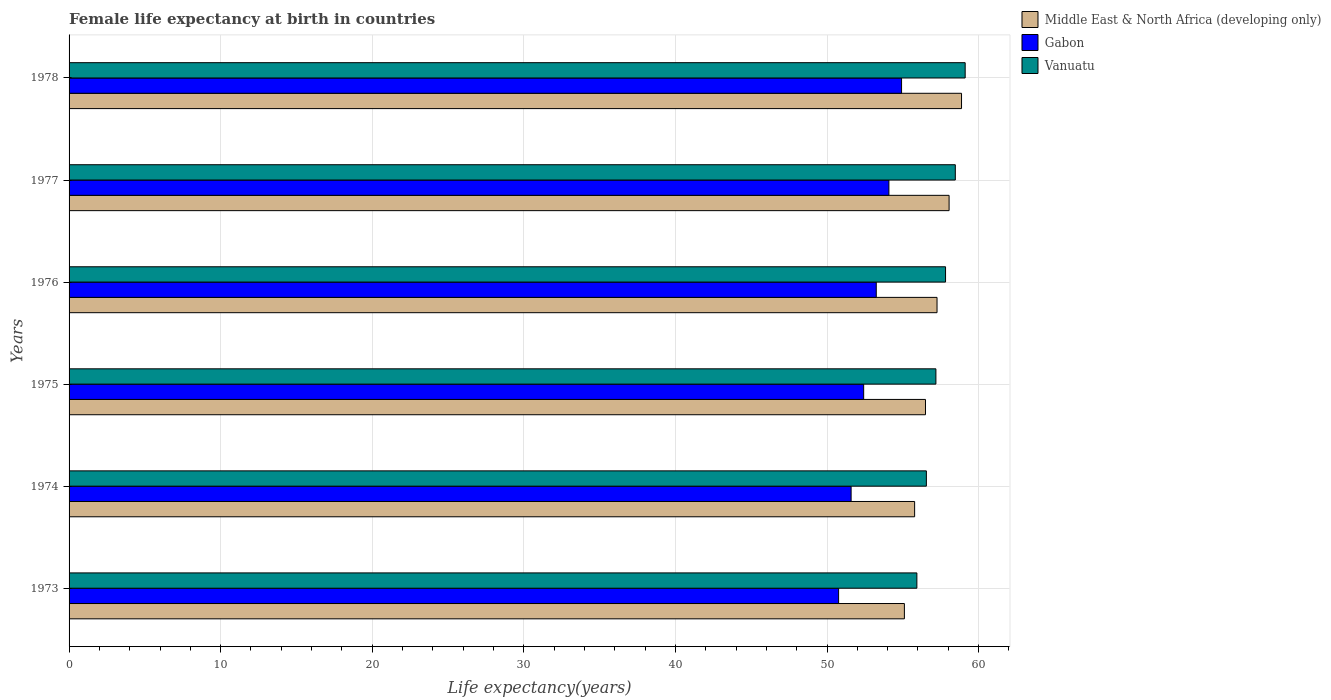How many different coloured bars are there?
Give a very brief answer. 3. How many groups of bars are there?
Offer a very short reply. 6. How many bars are there on the 1st tick from the top?
Your response must be concise. 3. How many bars are there on the 1st tick from the bottom?
Ensure brevity in your answer.  3. What is the label of the 3rd group of bars from the top?
Make the answer very short. 1976. What is the female life expectancy at birth in Middle East & North Africa (developing only) in 1975?
Your answer should be compact. 56.5. Across all years, what is the maximum female life expectancy at birth in Gabon?
Make the answer very short. 54.92. Across all years, what is the minimum female life expectancy at birth in Vanuatu?
Offer a terse response. 55.93. In which year was the female life expectancy at birth in Middle East & North Africa (developing only) maximum?
Provide a short and direct response. 1978. What is the total female life expectancy at birth in Middle East & North Africa (developing only) in the graph?
Your answer should be compact. 341.56. What is the difference between the female life expectancy at birth in Gabon in 1974 and that in 1975?
Make the answer very short. -0.83. What is the difference between the female life expectancy at birth in Gabon in 1977 and the female life expectancy at birth in Vanuatu in 1974?
Your response must be concise. -2.47. What is the average female life expectancy at birth in Vanuatu per year?
Keep it short and to the point. 57.51. In the year 1974, what is the difference between the female life expectancy at birth in Gabon and female life expectancy at birth in Vanuatu?
Provide a short and direct response. -4.97. What is the ratio of the female life expectancy at birth in Middle East & North Africa (developing only) in 1973 to that in 1978?
Offer a very short reply. 0.94. Is the female life expectancy at birth in Gabon in 1975 less than that in 1977?
Provide a short and direct response. Yes. Is the difference between the female life expectancy at birth in Gabon in 1973 and 1974 greater than the difference between the female life expectancy at birth in Vanuatu in 1973 and 1974?
Your answer should be compact. No. What is the difference between the highest and the second highest female life expectancy at birth in Middle East & North Africa (developing only)?
Make the answer very short. 0.82. What is the difference between the highest and the lowest female life expectancy at birth in Vanuatu?
Offer a very short reply. 3.19. In how many years, is the female life expectancy at birth in Gabon greater than the average female life expectancy at birth in Gabon taken over all years?
Provide a short and direct response. 3. Is the sum of the female life expectancy at birth in Vanuatu in 1976 and 1978 greater than the maximum female life expectancy at birth in Gabon across all years?
Offer a terse response. Yes. What does the 3rd bar from the top in 1978 represents?
Provide a short and direct response. Middle East & North Africa (developing only). What does the 1st bar from the bottom in 1976 represents?
Your answer should be very brief. Middle East & North Africa (developing only). How many bars are there?
Give a very brief answer. 18. Does the graph contain grids?
Your answer should be compact. Yes. Where does the legend appear in the graph?
Keep it short and to the point. Top right. How many legend labels are there?
Make the answer very short. 3. How are the legend labels stacked?
Ensure brevity in your answer.  Vertical. What is the title of the graph?
Provide a succinct answer. Female life expectancy at birth in countries. What is the label or title of the X-axis?
Give a very brief answer. Life expectancy(years). What is the Life expectancy(years) in Middle East & North Africa (developing only) in 1973?
Your answer should be very brief. 55.1. What is the Life expectancy(years) of Gabon in 1973?
Offer a very short reply. 50.76. What is the Life expectancy(years) in Vanuatu in 1973?
Offer a terse response. 55.93. What is the Life expectancy(years) in Middle East & North Africa (developing only) in 1974?
Offer a very short reply. 55.78. What is the Life expectancy(years) of Gabon in 1974?
Offer a very short reply. 51.59. What is the Life expectancy(years) of Vanuatu in 1974?
Ensure brevity in your answer.  56.55. What is the Life expectancy(years) of Middle East & North Africa (developing only) in 1975?
Your answer should be very brief. 56.5. What is the Life expectancy(years) in Gabon in 1975?
Your answer should be very brief. 52.42. What is the Life expectancy(years) in Vanuatu in 1975?
Keep it short and to the point. 57.18. What is the Life expectancy(years) in Middle East & North Africa (developing only) in 1976?
Keep it short and to the point. 57.26. What is the Life expectancy(years) in Gabon in 1976?
Offer a terse response. 53.25. What is the Life expectancy(years) of Vanuatu in 1976?
Your answer should be compact. 57.82. What is the Life expectancy(years) in Middle East & North Africa (developing only) in 1977?
Make the answer very short. 58.05. What is the Life expectancy(years) in Gabon in 1977?
Make the answer very short. 54.08. What is the Life expectancy(years) in Vanuatu in 1977?
Make the answer very short. 58.46. What is the Life expectancy(years) of Middle East & North Africa (developing only) in 1978?
Make the answer very short. 58.87. What is the Life expectancy(years) in Gabon in 1978?
Your answer should be very brief. 54.92. What is the Life expectancy(years) of Vanuatu in 1978?
Your response must be concise. 59.11. Across all years, what is the maximum Life expectancy(years) in Middle East & North Africa (developing only)?
Keep it short and to the point. 58.87. Across all years, what is the maximum Life expectancy(years) in Gabon?
Give a very brief answer. 54.92. Across all years, what is the maximum Life expectancy(years) of Vanuatu?
Your response must be concise. 59.11. Across all years, what is the minimum Life expectancy(years) in Middle East & North Africa (developing only)?
Your answer should be very brief. 55.1. Across all years, what is the minimum Life expectancy(years) in Gabon?
Ensure brevity in your answer.  50.76. Across all years, what is the minimum Life expectancy(years) of Vanuatu?
Provide a succinct answer. 55.93. What is the total Life expectancy(years) in Middle East & North Africa (developing only) in the graph?
Provide a succinct answer. 341.56. What is the total Life expectancy(years) in Gabon in the graph?
Offer a very short reply. 317.02. What is the total Life expectancy(years) of Vanuatu in the graph?
Ensure brevity in your answer.  345.06. What is the difference between the Life expectancy(years) of Middle East & North Africa (developing only) in 1973 and that in 1974?
Your answer should be very brief. -0.67. What is the difference between the Life expectancy(years) in Gabon in 1973 and that in 1974?
Your answer should be very brief. -0.82. What is the difference between the Life expectancy(years) in Vanuatu in 1973 and that in 1974?
Make the answer very short. -0.63. What is the difference between the Life expectancy(years) in Middle East & North Africa (developing only) in 1973 and that in 1975?
Your response must be concise. -1.39. What is the difference between the Life expectancy(years) of Gabon in 1973 and that in 1975?
Give a very brief answer. -1.65. What is the difference between the Life expectancy(years) of Vanuatu in 1973 and that in 1975?
Provide a succinct answer. -1.25. What is the difference between the Life expectancy(years) in Middle East & North Africa (developing only) in 1973 and that in 1976?
Provide a short and direct response. -2.15. What is the difference between the Life expectancy(years) in Gabon in 1973 and that in 1976?
Your answer should be compact. -2.48. What is the difference between the Life expectancy(years) in Vanuatu in 1973 and that in 1976?
Your response must be concise. -1.89. What is the difference between the Life expectancy(years) of Middle East & North Africa (developing only) in 1973 and that in 1977?
Keep it short and to the point. -2.95. What is the difference between the Life expectancy(years) in Gabon in 1973 and that in 1977?
Offer a terse response. -3.32. What is the difference between the Life expectancy(years) of Vanuatu in 1973 and that in 1977?
Your answer should be compact. -2.54. What is the difference between the Life expectancy(years) of Middle East & North Africa (developing only) in 1973 and that in 1978?
Make the answer very short. -3.77. What is the difference between the Life expectancy(years) in Gabon in 1973 and that in 1978?
Offer a terse response. -4.15. What is the difference between the Life expectancy(years) in Vanuatu in 1973 and that in 1978?
Offer a terse response. -3.19. What is the difference between the Life expectancy(years) of Middle East & North Africa (developing only) in 1974 and that in 1975?
Give a very brief answer. -0.72. What is the difference between the Life expectancy(years) of Gabon in 1974 and that in 1975?
Your answer should be compact. -0.83. What is the difference between the Life expectancy(years) of Vanuatu in 1974 and that in 1975?
Your answer should be compact. -0.63. What is the difference between the Life expectancy(years) of Middle East & North Africa (developing only) in 1974 and that in 1976?
Offer a terse response. -1.48. What is the difference between the Life expectancy(years) of Gabon in 1974 and that in 1976?
Give a very brief answer. -1.66. What is the difference between the Life expectancy(years) of Vanuatu in 1974 and that in 1976?
Give a very brief answer. -1.26. What is the difference between the Life expectancy(years) of Middle East & North Africa (developing only) in 1974 and that in 1977?
Ensure brevity in your answer.  -2.27. What is the difference between the Life expectancy(years) of Gabon in 1974 and that in 1977?
Provide a succinct answer. -2.49. What is the difference between the Life expectancy(years) of Vanuatu in 1974 and that in 1977?
Offer a terse response. -1.91. What is the difference between the Life expectancy(years) in Middle East & North Africa (developing only) in 1974 and that in 1978?
Your answer should be compact. -3.09. What is the difference between the Life expectancy(years) in Gabon in 1974 and that in 1978?
Provide a succinct answer. -3.33. What is the difference between the Life expectancy(years) in Vanuatu in 1974 and that in 1978?
Provide a succinct answer. -2.56. What is the difference between the Life expectancy(years) of Middle East & North Africa (developing only) in 1975 and that in 1976?
Make the answer very short. -0.76. What is the difference between the Life expectancy(years) of Gabon in 1975 and that in 1976?
Your answer should be compact. -0.83. What is the difference between the Life expectancy(years) of Vanuatu in 1975 and that in 1976?
Make the answer very short. -0.64. What is the difference between the Life expectancy(years) of Middle East & North Africa (developing only) in 1975 and that in 1977?
Offer a very short reply. -1.56. What is the difference between the Life expectancy(years) of Gabon in 1975 and that in 1977?
Make the answer very short. -1.67. What is the difference between the Life expectancy(years) in Vanuatu in 1975 and that in 1977?
Your answer should be compact. -1.28. What is the difference between the Life expectancy(years) in Middle East & North Africa (developing only) in 1975 and that in 1978?
Give a very brief answer. -2.38. What is the difference between the Life expectancy(years) in Gabon in 1975 and that in 1978?
Provide a short and direct response. -2.5. What is the difference between the Life expectancy(years) of Vanuatu in 1975 and that in 1978?
Your response must be concise. -1.93. What is the difference between the Life expectancy(years) in Middle East & North Africa (developing only) in 1976 and that in 1977?
Make the answer very short. -0.8. What is the difference between the Life expectancy(years) in Gabon in 1976 and that in 1977?
Ensure brevity in your answer.  -0.83. What is the difference between the Life expectancy(years) in Vanuatu in 1976 and that in 1977?
Your answer should be compact. -0.65. What is the difference between the Life expectancy(years) in Middle East & North Africa (developing only) in 1976 and that in 1978?
Your response must be concise. -1.62. What is the difference between the Life expectancy(years) of Gabon in 1976 and that in 1978?
Ensure brevity in your answer.  -1.67. What is the difference between the Life expectancy(years) of Vanuatu in 1976 and that in 1978?
Your response must be concise. -1.29. What is the difference between the Life expectancy(years) of Middle East & North Africa (developing only) in 1977 and that in 1978?
Offer a very short reply. -0.82. What is the difference between the Life expectancy(years) in Gabon in 1977 and that in 1978?
Keep it short and to the point. -0.83. What is the difference between the Life expectancy(years) of Vanuatu in 1977 and that in 1978?
Give a very brief answer. -0.65. What is the difference between the Life expectancy(years) in Middle East & North Africa (developing only) in 1973 and the Life expectancy(years) in Gabon in 1974?
Keep it short and to the point. 3.51. What is the difference between the Life expectancy(years) in Middle East & North Africa (developing only) in 1973 and the Life expectancy(years) in Vanuatu in 1974?
Offer a terse response. -1.45. What is the difference between the Life expectancy(years) of Gabon in 1973 and the Life expectancy(years) of Vanuatu in 1974?
Your answer should be compact. -5.79. What is the difference between the Life expectancy(years) in Middle East & North Africa (developing only) in 1973 and the Life expectancy(years) in Gabon in 1975?
Your answer should be very brief. 2.69. What is the difference between the Life expectancy(years) in Middle East & North Africa (developing only) in 1973 and the Life expectancy(years) in Vanuatu in 1975?
Your answer should be compact. -2.08. What is the difference between the Life expectancy(years) of Gabon in 1973 and the Life expectancy(years) of Vanuatu in 1975?
Provide a succinct answer. -6.42. What is the difference between the Life expectancy(years) in Middle East & North Africa (developing only) in 1973 and the Life expectancy(years) in Gabon in 1976?
Offer a very short reply. 1.86. What is the difference between the Life expectancy(years) in Middle East & North Africa (developing only) in 1973 and the Life expectancy(years) in Vanuatu in 1976?
Offer a very short reply. -2.71. What is the difference between the Life expectancy(years) of Gabon in 1973 and the Life expectancy(years) of Vanuatu in 1976?
Make the answer very short. -7.05. What is the difference between the Life expectancy(years) of Middle East & North Africa (developing only) in 1973 and the Life expectancy(years) of Gabon in 1977?
Keep it short and to the point. 1.02. What is the difference between the Life expectancy(years) of Middle East & North Africa (developing only) in 1973 and the Life expectancy(years) of Vanuatu in 1977?
Offer a very short reply. -3.36. What is the difference between the Life expectancy(years) of Gabon in 1973 and the Life expectancy(years) of Vanuatu in 1977?
Ensure brevity in your answer.  -7.7. What is the difference between the Life expectancy(years) of Middle East & North Africa (developing only) in 1973 and the Life expectancy(years) of Gabon in 1978?
Your answer should be compact. 0.19. What is the difference between the Life expectancy(years) in Middle East & North Africa (developing only) in 1973 and the Life expectancy(years) in Vanuatu in 1978?
Offer a very short reply. -4.01. What is the difference between the Life expectancy(years) of Gabon in 1973 and the Life expectancy(years) of Vanuatu in 1978?
Provide a succinct answer. -8.35. What is the difference between the Life expectancy(years) of Middle East & North Africa (developing only) in 1974 and the Life expectancy(years) of Gabon in 1975?
Offer a very short reply. 3.36. What is the difference between the Life expectancy(years) of Middle East & North Africa (developing only) in 1974 and the Life expectancy(years) of Vanuatu in 1975?
Your response must be concise. -1.4. What is the difference between the Life expectancy(years) of Gabon in 1974 and the Life expectancy(years) of Vanuatu in 1975?
Keep it short and to the point. -5.59. What is the difference between the Life expectancy(years) in Middle East & North Africa (developing only) in 1974 and the Life expectancy(years) in Gabon in 1976?
Offer a terse response. 2.53. What is the difference between the Life expectancy(years) in Middle East & North Africa (developing only) in 1974 and the Life expectancy(years) in Vanuatu in 1976?
Offer a terse response. -2.04. What is the difference between the Life expectancy(years) of Gabon in 1974 and the Life expectancy(years) of Vanuatu in 1976?
Make the answer very short. -6.23. What is the difference between the Life expectancy(years) of Middle East & North Africa (developing only) in 1974 and the Life expectancy(years) of Gabon in 1977?
Make the answer very short. 1.7. What is the difference between the Life expectancy(years) in Middle East & North Africa (developing only) in 1974 and the Life expectancy(years) in Vanuatu in 1977?
Provide a short and direct response. -2.68. What is the difference between the Life expectancy(years) in Gabon in 1974 and the Life expectancy(years) in Vanuatu in 1977?
Keep it short and to the point. -6.87. What is the difference between the Life expectancy(years) in Middle East & North Africa (developing only) in 1974 and the Life expectancy(years) in Gabon in 1978?
Your answer should be compact. 0.86. What is the difference between the Life expectancy(years) in Middle East & North Africa (developing only) in 1974 and the Life expectancy(years) in Vanuatu in 1978?
Make the answer very short. -3.33. What is the difference between the Life expectancy(years) of Gabon in 1974 and the Life expectancy(years) of Vanuatu in 1978?
Make the answer very short. -7.52. What is the difference between the Life expectancy(years) of Middle East & North Africa (developing only) in 1975 and the Life expectancy(years) of Gabon in 1976?
Provide a short and direct response. 3.25. What is the difference between the Life expectancy(years) of Middle East & North Africa (developing only) in 1975 and the Life expectancy(years) of Vanuatu in 1976?
Offer a terse response. -1.32. What is the difference between the Life expectancy(years) of Gabon in 1975 and the Life expectancy(years) of Vanuatu in 1976?
Your answer should be very brief. -5.4. What is the difference between the Life expectancy(years) in Middle East & North Africa (developing only) in 1975 and the Life expectancy(years) in Gabon in 1977?
Your answer should be very brief. 2.41. What is the difference between the Life expectancy(years) of Middle East & North Africa (developing only) in 1975 and the Life expectancy(years) of Vanuatu in 1977?
Offer a terse response. -1.97. What is the difference between the Life expectancy(years) of Gabon in 1975 and the Life expectancy(years) of Vanuatu in 1977?
Your answer should be very brief. -6.05. What is the difference between the Life expectancy(years) in Middle East & North Africa (developing only) in 1975 and the Life expectancy(years) in Gabon in 1978?
Provide a succinct answer. 1.58. What is the difference between the Life expectancy(years) of Middle East & North Africa (developing only) in 1975 and the Life expectancy(years) of Vanuatu in 1978?
Keep it short and to the point. -2.62. What is the difference between the Life expectancy(years) in Gabon in 1975 and the Life expectancy(years) in Vanuatu in 1978?
Provide a short and direct response. -6.7. What is the difference between the Life expectancy(years) in Middle East & North Africa (developing only) in 1976 and the Life expectancy(years) in Gabon in 1977?
Ensure brevity in your answer.  3.17. What is the difference between the Life expectancy(years) in Middle East & North Africa (developing only) in 1976 and the Life expectancy(years) in Vanuatu in 1977?
Your answer should be very brief. -1.21. What is the difference between the Life expectancy(years) of Gabon in 1976 and the Life expectancy(years) of Vanuatu in 1977?
Your answer should be very brief. -5.21. What is the difference between the Life expectancy(years) of Middle East & North Africa (developing only) in 1976 and the Life expectancy(years) of Gabon in 1978?
Ensure brevity in your answer.  2.34. What is the difference between the Life expectancy(years) in Middle East & North Africa (developing only) in 1976 and the Life expectancy(years) in Vanuatu in 1978?
Give a very brief answer. -1.86. What is the difference between the Life expectancy(years) of Gabon in 1976 and the Life expectancy(years) of Vanuatu in 1978?
Ensure brevity in your answer.  -5.87. What is the difference between the Life expectancy(years) in Middle East & North Africa (developing only) in 1977 and the Life expectancy(years) in Gabon in 1978?
Keep it short and to the point. 3.13. What is the difference between the Life expectancy(years) of Middle East & North Africa (developing only) in 1977 and the Life expectancy(years) of Vanuatu in 1978?
Provide a succinct answer. -1.06. What is the difference between the Life expectancy(years) of Gabon in 1977 and the Life expectancy(years) of Vanuatu in 1978?
Keep it short and to the point. -5.03. What is the average Life expectancy(years) of Middle East & North Africa (developing only) per year?
Offer a terse response. 56.93. What is the average Life expectancy(years) in Gabon per year?
Make the answer very short. 52.84. What is the average Life expectancy(years) of Vanuatu per year?
Your response must be concise. 57.51. In the year 1973, what is the difference between the Life expectancy(years) of Middle East & North Africa (developing only) and Life expectancy(years) of Gabon?
Offer a very short reply. 4.34. In the year 1973, what is the difference between the Life expectancy(years) of Middle East & North Africa (developing only) and Life expectancy(years) of Vanuatu?
Ensure brevity in your answer.  -0.82. In the year 1973, what is the difference between the Life expectancy(years) in Gabon and Life expectancy(years) in Vanuatu?
Keep it short and to the point. -5.16. In the year 1974, what is the difference between the Life expectancy(years) of Middle East & North Africa (developing only) and Life expectancy(years) of Gabon?
Your answer should be compact. 4.19. In the year 1974, what is the difference between the Life expectancy(years) of Middle East & North Africa (developing only) and Life expectancy(years) of Vanuatu?
Ensure brevity in your answer.  -0.78. In the year 1974, what is the difference between the Life expectancy(years) of Gabon and Life expectancy(years) of Vanuatu?
Make the answer very short. -4.96. In the year 1975, what is the difference between the Life expectancy(years) in Middle East & North Africa (developing only) and Life expectancy(years) in Gabon?
Give a very brief answer. 4.08. In the year 1975, what is the difference between the Life expectancy(years) of Middle East & North Africa (developing only) and Life expectancy(years) of Vanuatu?
Give a very brief answer. -0.69. In the year 1975, what is the difference between the Life expectancy(years) in Gabon and Life expectancy(years) in Vanuatu?
Offer a very short reply. -4.76. In the year 1976, what is the difference between the Life expectancy(years) of Middle East & North Africa (developing only) and Life expectancy(years) of Gabon?
Offer a terse response. 4.01. In the year 1976, what is the difference between the Life expectancy(years) in Middle East & North Africa (developing only) and Life expectancy(years) in Vanuatu?
Provide a short and direct response. -0.56. In the year 1976, what is the difference between the Life expectancy(years) in Gabon and Life expectancy(years) in Vanuatu?
Offer a very short reply. -4.57. In the year 1977, what is the difference between the Life expectancy(years) of Middle East & North Africa (developing only) and Life expectancy(years) of Gabon?
Your answer should be very brief. 3.97. In the year 1977, what is the difference between the Life expectancy(years) in Middle East & North Africa (developing only) and Life expectancy(years) in Vanuatu?
Keep it short and to the point. -0.41. In the year 1977, what is the difference between the Life expectancy(years) in Gabon and Life expectancy(years) in Vanuatu?
Give a very brief answer. -4.38. In the year 1978, what is the difference between the Life expectancy(years) in Middle East & North Africa (developing only) and Life expectancy(years) in Gabon?
Give a very brief answer. 3.96. In the year 1978, what is the difference between the Life expectancy(years) in Middle East & North Africa (developing only) and Life expectancy(years) in Vanuatu?
Make the answer very short. -0.24. In the year 1978, what is the difference between the Life expectancy(years) in Gabon and Life expectancy(years) in Vanuatu?
Keep it short and to the point. -4.2. What is the ratio of the Life expectancy(years) in Middle East & North Africa (developing only) in 1973 to that in 1974?
Make the answer very short. 0.99. What is the ratio of the Life expectancy(years) of Gabon in 1973 to that in 1974?
Give a very brief answer. 0.98. What is the ratio of the Life expectancy(years) in Vanuatu in 1973 to that in 1974?
Offer a very short reply. 0.99. What is the ratio of the Life expectancy(years) of Middle East & North Africa (developing only) in 1973 to that in 1975?
Provide a succinct answer. 0.98. What is the ratio of the Life expectancy(years) of Gabon in 1973 to that in 1975?
Keep it short and to the point. 0.97. What is the ratio of the Life expectancy(years) of Vanuatu in 1973 to that in 1975?
Your answer should be compact. 0.98. What is the ratio of the Life expectancy(years) of Middle East & North Africa (developing only) in 1973 to that in 1976?
Ensure brevity in your answer.  0.96. What is the ratio of the Life expectancy(years) of Gabon in 1973 to that in 1976?
Offer a terse response. 0.95. What is the ratio of the Life expectancy(years) in Vanuatu in 1973 to that in 1976?
Ensure brevity in your answer.  0.97. What is the ratio of the Life expectancy(years) in Middle East & North Africa (developing only) in 1973 to that in 1977?
Give a very brief answer. 0.95. What is the ratio of the Life expectancy(years) in Gabon in 1973 to that in 1977?
Provide a succinct answer. 0.94. What is the ratio of the Life expectancy(years) of Vanuatu in 1973 to that in 1977?
Provide a succinct answer. 0.96. What is the ratio of the Life expectancy(years) of Middle East & North Africa (developing only) in 1973 to that in 1978?
Provide a succinct answer. 0.94. What is the ratio of the Life expectancy(years) of Gabon in 1973 to that in 1978?
Your answer should be very brief. 0.92. What is the ratio of the Life expectancy(years) in Vanuatu in 1973 to that in 1978?
Your response must be concise. 0.95. What is the ratio of the Life expectancy(years) of Middle East & North Africa (developing only) in 1974 to that in 1975?
Offer a very short reply. 0.99. What is the ratio of the Life expectancy(years) of Gabon in 1974 to that in 1975?
Your response must be concise. 0.98. What is the ratio of the Life expectancy(years) in Middle East & North Africa (developing only) in 1974 to that in 1976?
Give a very brief answer. 0.97. What is the ratio of the Life expectancy(years) of Gabon in 1974 to that in 1976?
Offer a very short reply. 0.97. What is the ratio of the Life expectancy(years) of Vanuatu in 1974 to that in 1976?
Ensure brevity in your answer.  0.98. What is the ratio of the Life expectancy(years) in Middle East & North Africa (developing only) in 1974 to that in 1977?
Offer a very short reply. 0.96. What is the ratio of the Life expectancy(years) of Gabon in 1974 to that in 1977?
Provide a succinct answer. 0.95. What is the ratio of the Life expectancy(years) in Vanuatu in 1974 to that in 1977?
Give a very brief answer. 0.97. What is the ratio of the Life expectancy(years) of Gabon in 1974 to that in 1978?
Your answer should be very brief. 0.94. What is the ratio of the Life expectancy(years) in Vanuatu in 1974 to that in 1978?
Keep it short and to the point. 0.96. What is the ratio of the Life expectancy(years) in Middle East & North Africa (developing only) in 1975 to that in 1976?
Your answer should be very brief. 0.99. What is the ratio of the Life expectancy(years) in Gabon in 1975 to that in 1976?
Ensure brevity in your answer.  0.98. What is the ratio of the Life expectancy(years) of Vanuatu in 1975 to that in 1976?
Offer a terse response. 0.99. What is the ratio of the Life expectancy(years) in Middle East & North Africa (developing only) in 1975 to that in 1977?
Your response must be concise. 0.97. What is the ratio of the Life expectancy(years) in Gabon in 1975 to that in 1977?
Offer a very short reply. 0.97. What is the ratio of the Life expectancy(years) of Vanuatu in 1975 to that in 1977?
Your answer should be very brief. 0.98. What is the ratio of the Life expectancy(years) of Middle East & North Africa (developing only) in 1975 to that in 1978?
Provide a short and direct response. 0.96. What is the ratio of the Life expectancy(years) in Gabon in 1975 to that in 1978?
Give a very brief answer. 0.95. What is the ratio of the Life expectancy(years) of Vanuatu in 1975 to that in 1978?
Ensure brevity in your answer.  0.97. What is the ratio of the Life expectancy(years) of Middle East & North Africa (developing only) in 1976 to that in 1977?
Keep it short and to the point. 0.99. What is the ratio of the Life expectancy(years) in Gabon in 1976 to that in 1977?
Your answer should be compact. 0.98. What is the ratio of the Life expectancy(years) of Middle East & North Africa (developing only) in 1976 to that in 1978?
Keep it short and to the point. 0.97. What is the ratio of the Life expectancy(years) in Gabon in 1976 to that in 1978?
Your response must be concise. 0.97. What is the ratio of the Life expectancy(years) in Vanuatu in 1976 to that in 1978?
Ensure brevity in your answer.  0.98. What is the ratio of the Life expectancy(years) in Middle East & North Africa (developing only) in 1977 to that in 1978?
Offer a terse response. 0.99. What is the ratio of the Life expectancy(years) in Vanuatu in 1977 to that in 1978?
Make the answer very short. 0.99. What is the difference between the highest and the second highest Life expectancy(years) of Middle East & North Africa (developing only)?
Offer a terse response. 0.82. What is the difference between the highest and the second highest Life expectancy(years) of Gabon?
Keep it short and to the point. 0.83. What is the difference between the highest and the second highest Life expectancy(years) in Vanuatu?
Provide a succinct answer. 0.65. What is the difference between the highest and the lowest Life expectancy(years) in Middle East & North Africa (developing only)?
Give a very brief answer. 3.77. What is the difference between the highest and the lowest Life expectancy(years) of Gabon?
Your answer should be very brief. 4.15. What is the difference between the highest and the lowest Life expectancy(years) of Vanuatu?
Ensure brevity in your answer.  3.19. 